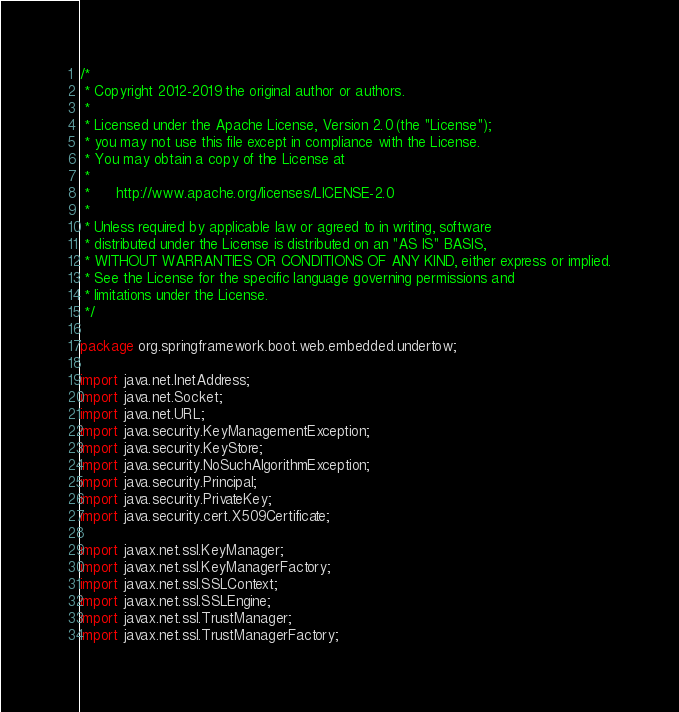<code> <loc_0><loc_0><loc_500><loc_500><_Java_>/*
 * Copyright 2012-2019 the original author or authors.
 *
 * Licensed under the Apache License, Version 2.0 (the "License");
 * you may not use this file except in compliance with the License.
 * You may obtain a copy of the License at
 *
 *      http://www.apache.org/licenses/LICENSE-2.0
 *
 * Unless required by applicable law or agreed to in writing, software
 * distributed under the License is distributed on an "AS IS" BASIS,
 * WITHOUT WARRANTIES OR CONDITIONS OF ANY KIND, either express or implied.
 * See the License for the specific language governing permissions and
 * limitations under the License.
 */

package org.springframework.boot.web.embedded.undertow;

import java.net.InetAddress;
import java.net.Socket;
import java.net.URL;
import java.security.KeyManagementException;
import java.security.KeyStore;
import java.security.NoSuchAlgorithmException;
import java.security.Principal;
import java.security.PrivateKey;
import java.security.cert.X509Certificate;

import javax.net.ssl.KeyManager;
import javax.net.ssl.KeyManagerFactory;
import javax.net.ssl.SSLContext;
import javax.net.ssl.SSLEngine;
import javax.net.ssl.TrustManager;
import javax.net.ssl.TrustManagerFactory;</code> 